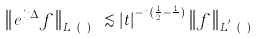Convert formula to latex. <formula><loc_0><loc_0><loc_500><loc_500>\left \| e ^ { i t \Delta } f \right \| _ { L ^ { p } ( \mathbb { R } ^ { n } ) } \lesssim | t | ^ { - n ( \frac { 1 } { 2 } - \frac { 1 } { p } ) } \left \| f \right \| _ { L ^ { p ^ { \prime } } ( \mathbb { R } ^ { n } ) }</formula> 